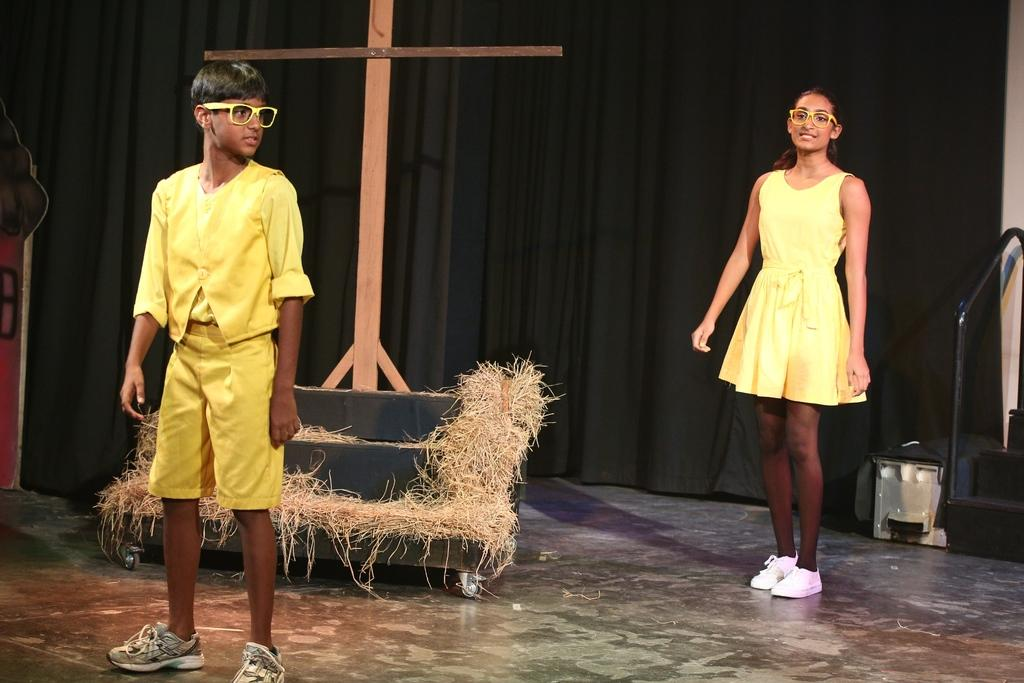How many people are in the image? There are two people standing in the image. What are the people wearing? The people are wearing yellow costumes. What is the main object in the center of the image? There is a cross in the center of the image. What type of ground is visible in the image? There is grass in the image. What can be seen in the background of the image? There is a curtain and stairs visible in the background of the image. What season is depicted in the image? The provided facts do not mention any seasonal details, so it cannot be determined from the image. 